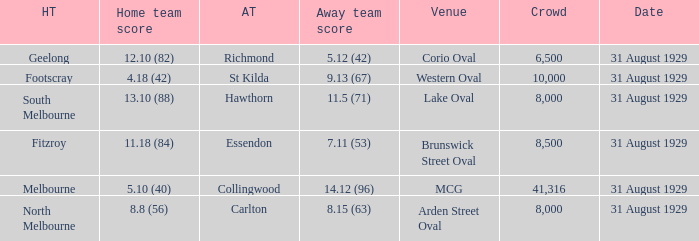What is the largest crowd when the away team is Hawthorn? 8000.0. 